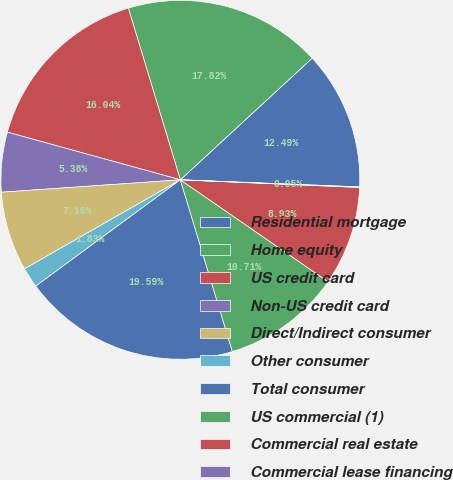Convert chart to OTSL. <chart><loc_0><loc_0><loc_500><loc_500><pie_chart><fcel>Residential mortgage<fcel>Home equity<fcel>US credit card<fcel>Non-US credit card<fcel>Direct/Indirect consumer<fcel>Other consumer<fcel>Total consumer<fcel>US commercial (1)<fcel>Commercial real estate<fcel>Commercial lease financing<nl><fcel>12.49%<fcel>17.82%<fcel>16.04%<fcel>5.38%<fcel>7.16%<fcel>1.83%<fcel>19.59%<fcel>10.71%<fcel>8.93%<fcel>0.05%<nl></chart> 